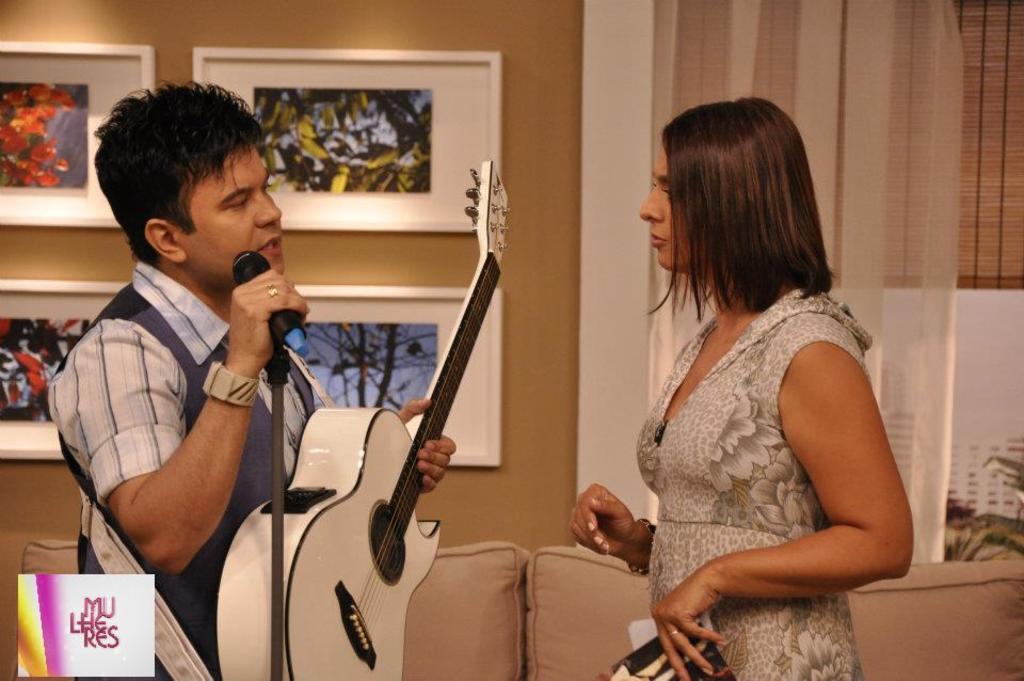How would you summarize this image in a sentence or two? On the right side of the image we can see a woman standing. On the left side of the image we can see a man standing while holding a mic and guitar in his hands. In the background we can see sofa, photo frames on the wall. 